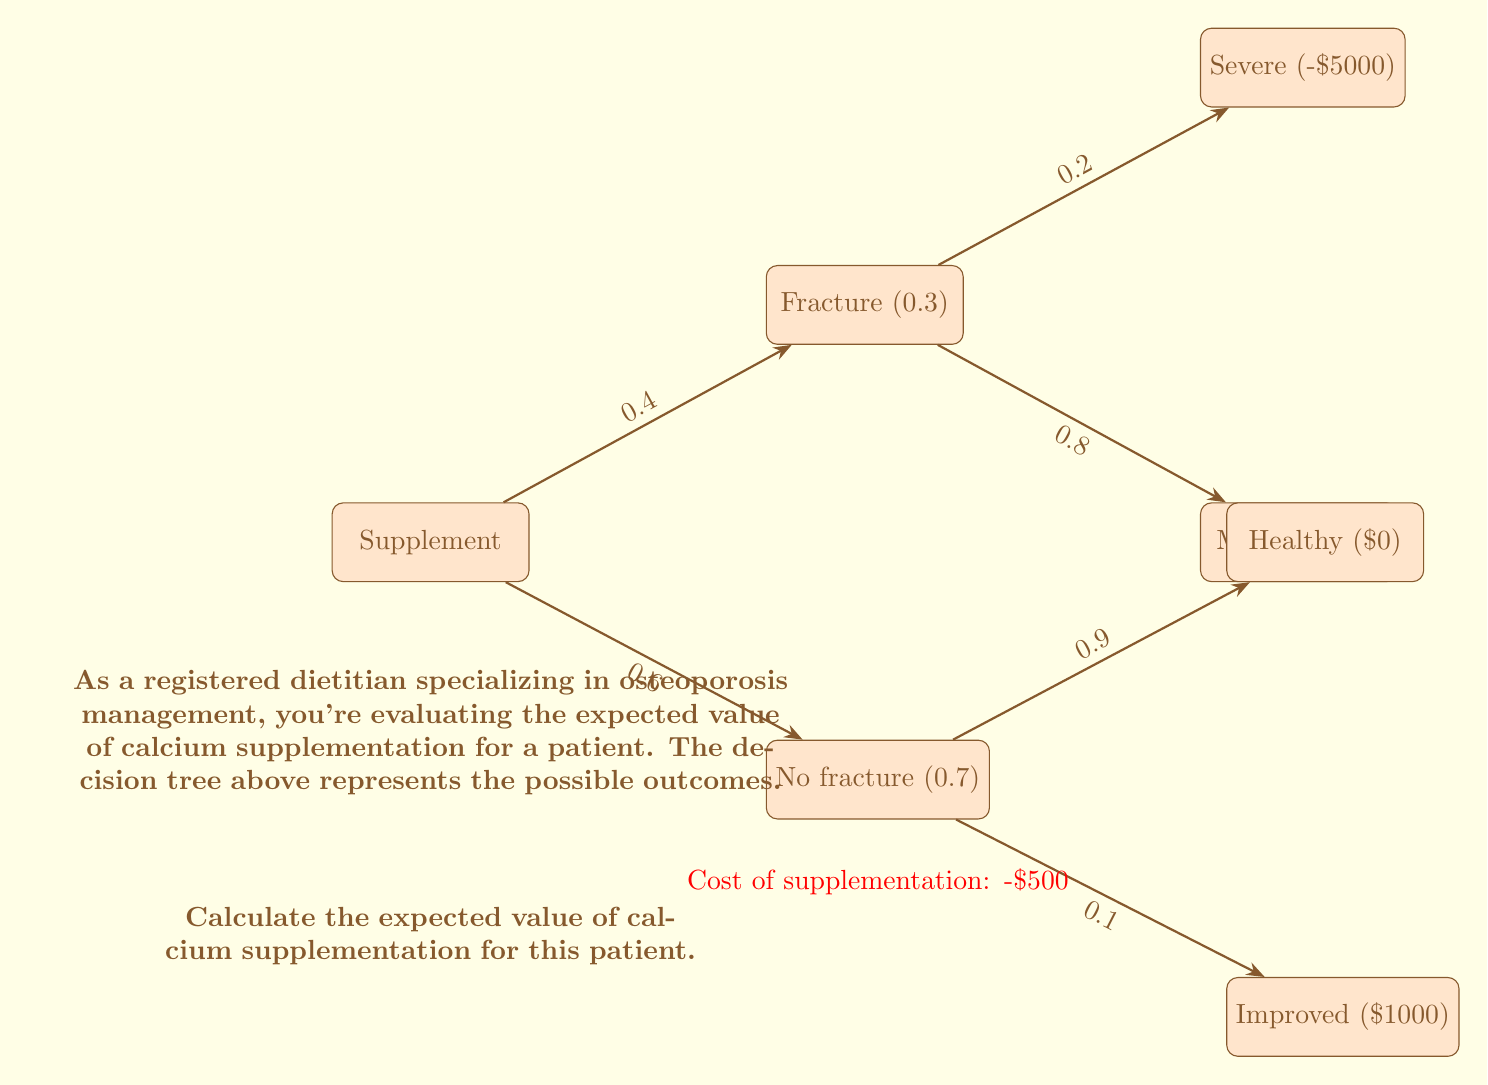Provide a solution to this math problem. Let's approach this step-by-step:

1) First, we need to calculate the expected value of each branch:

   Fracture branch:
   $$E(\text{Fracture}) = 0.2 \cdot (-5000) + 0.8 \cdot (-2000) = -2600$$

   No fracture branch:
   $$E(\text{No fracture}) = 0.9 \cdot 0 + 0.1 \cdot 1000 = 100$$

2) Now, we calculate the expected value of the decision to supplement:

   $$E(\text{Supplement}) = 0.4 \cdot E(\text{Fracture}) + 0.6 \cdot E(\text{No fracture}) - 500$$
   $$E(\text{Supplement}) = 0.4 \cdot (-2600) + 0.6 \cdot 100 - 500$$
   $$E(\text{Supplement}) = -1040 + 60 - 500 = -1480$$

3) Therefore, the expected value of calcium supplementation is -$1480.

This means that, on average, the patient would lose $1480 by choosing to supplement with calcium, considering the probabilities of different outcomes and the cost of supplementation.
Answer: -$1480 